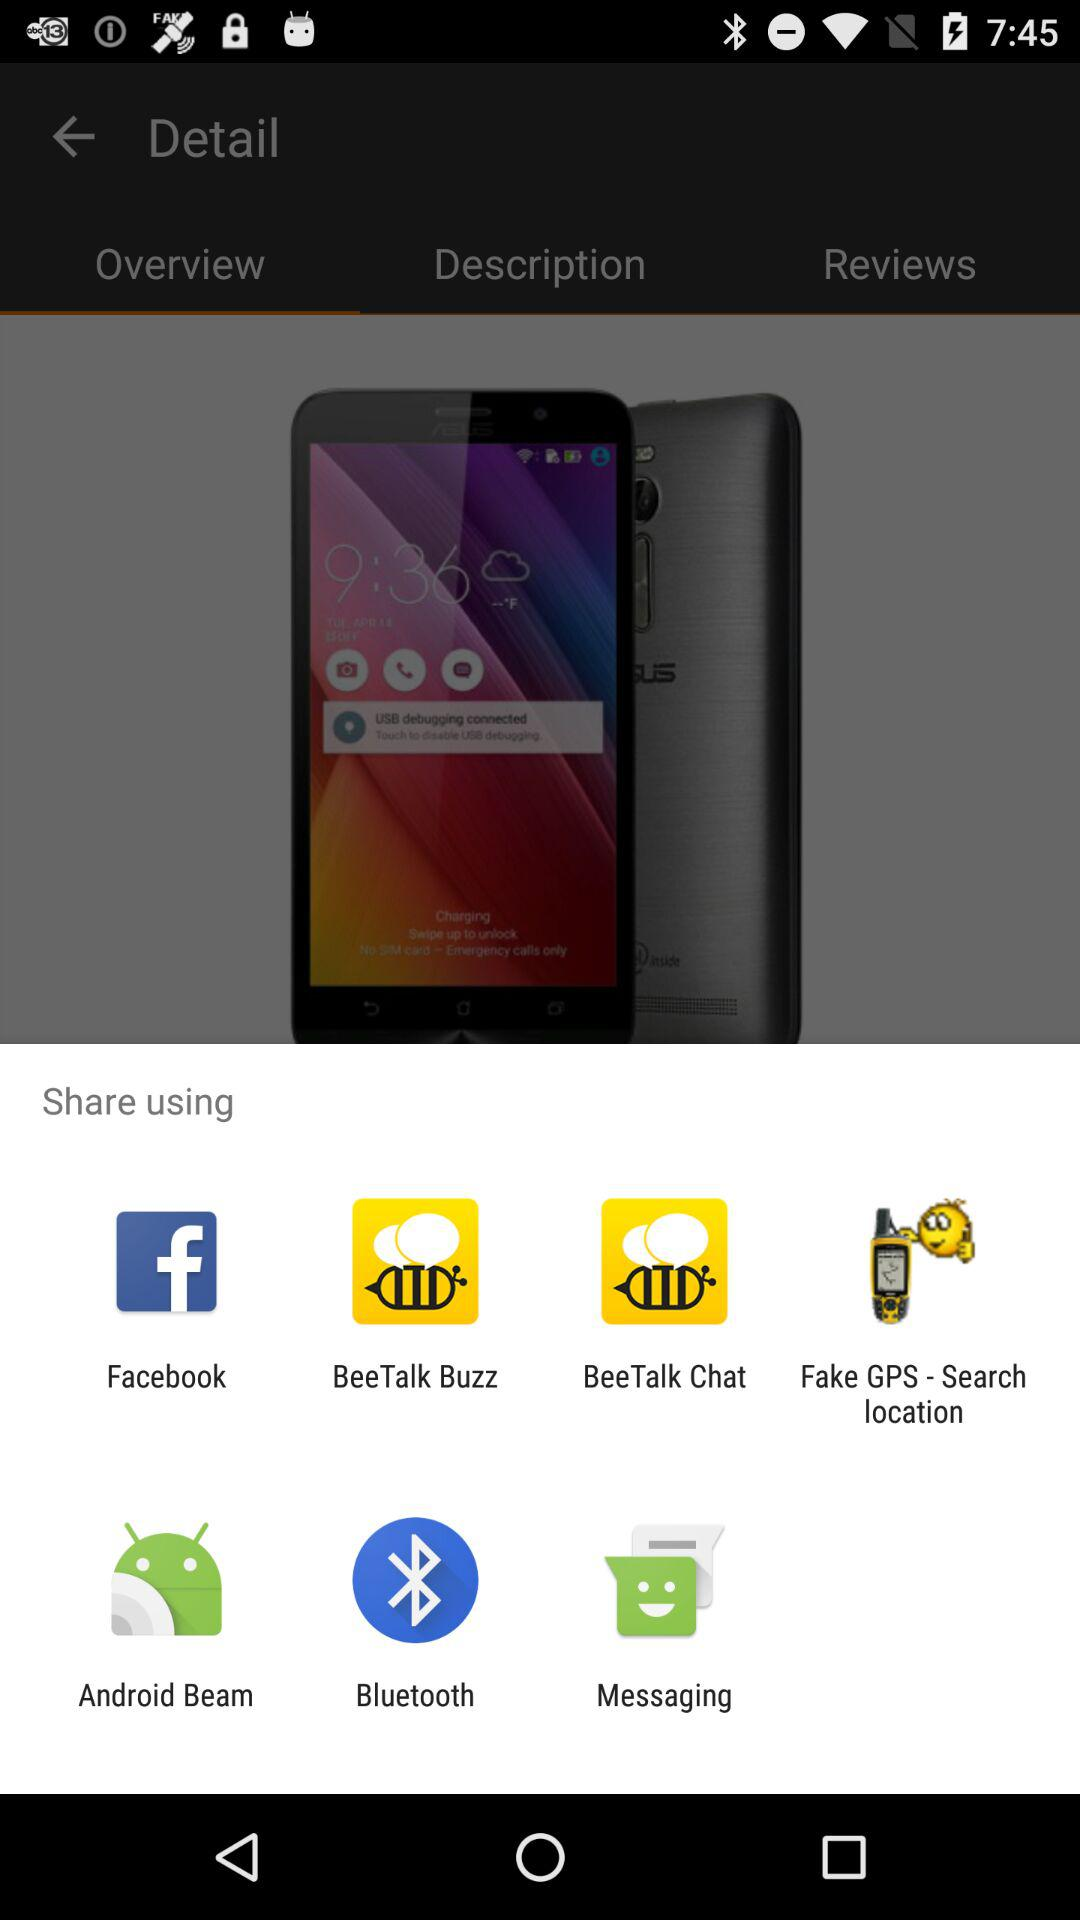Through which app can we share? You can share through "Facebook", "BeeTalk Buzz", "BeeTalk Chat", "Fake GPS - Search location", "Android Beam", "Bluetooth" and "Messaging". 